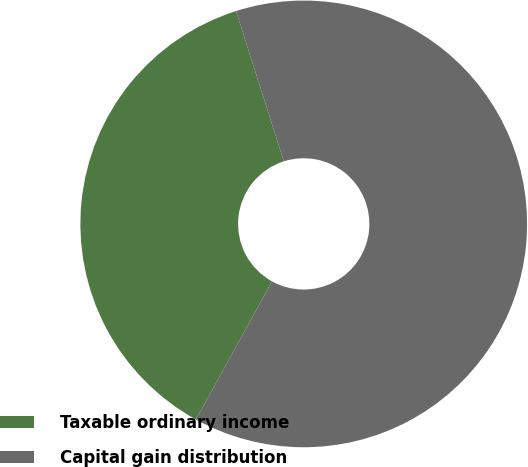Convert chart. <chart><loc_0><loc_0><loc_500><loc_500><pie_chart><fcel>Taxable ordinary income<fcel>Capital gain distribution<nl><fcel>37.08%<fcel>62.92%<nl></chart> 